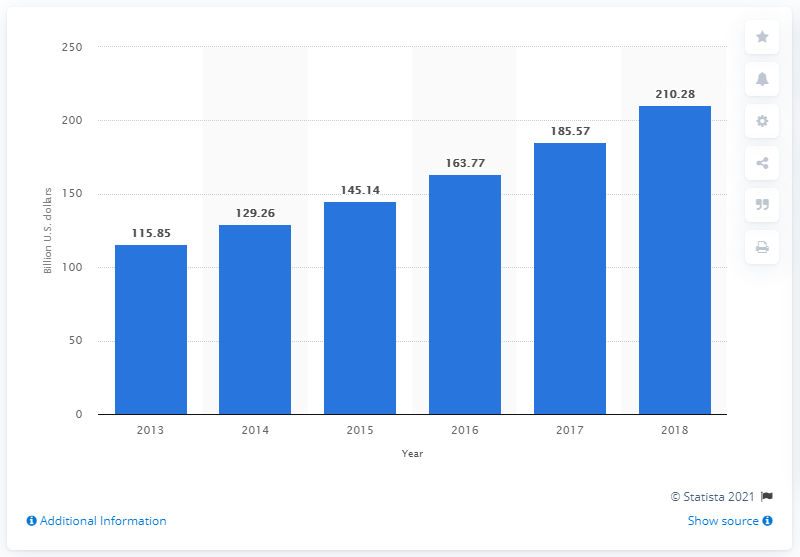Indicate a few pertinent items in this graphic. In 2018, Pakistan's retail spending was forecasted to reach 210.28 billion U.S. dollars. 